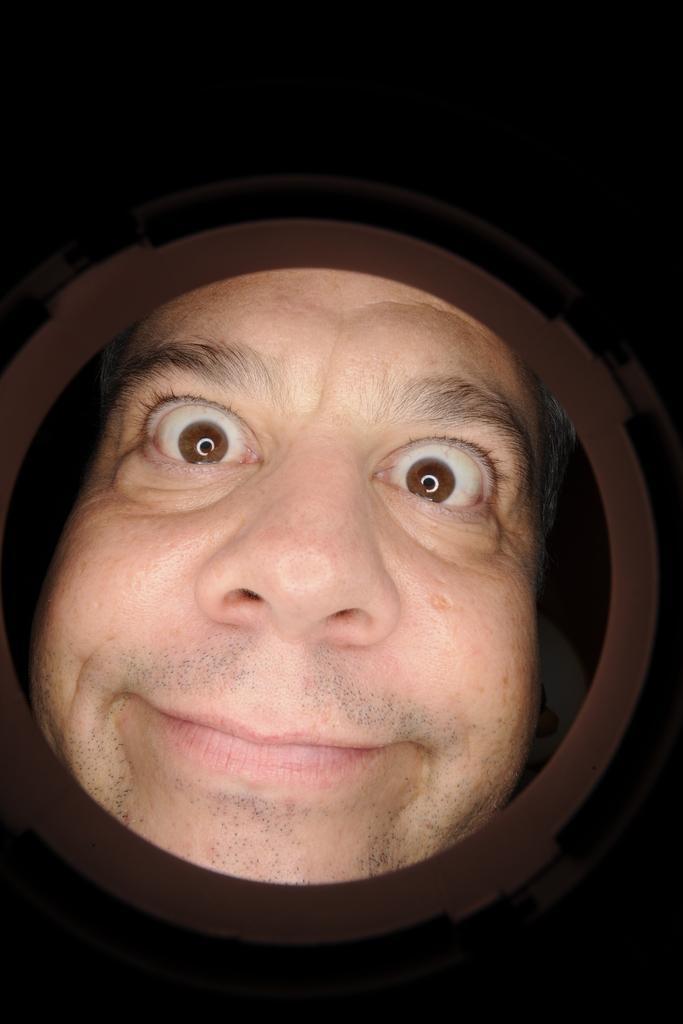Describe this image in one or two sentences. In the image there is a person looking into the hole, his expression is weird. 